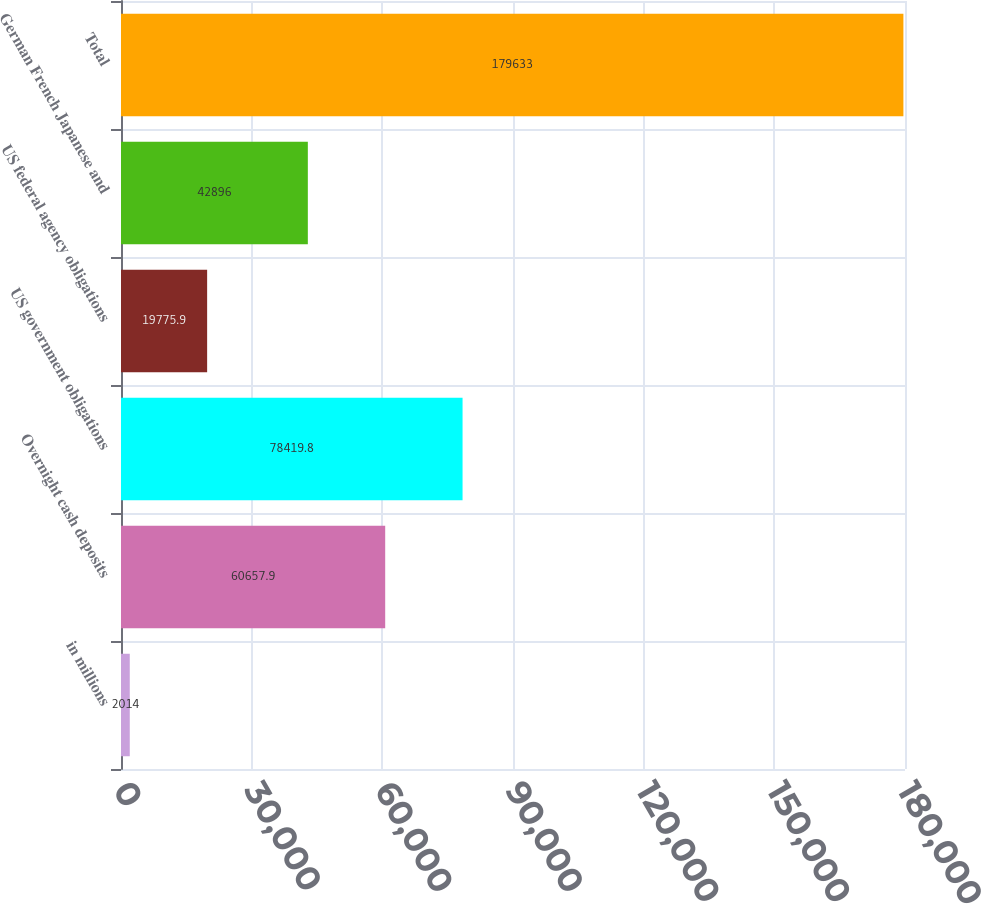<chart> <loc_0><loc_0><loc_500><loc_500><bar_chart><fcel>in millions<fcel>Overnight cash deposits<fcel>US government obligations<fcel>US federal agency obligations<fcel>German French Japanese and<fcel>Total<nl><fcel>2014<fcel>60657.9<fcel>78419.8<fcel>19775.9<fcel>42896<fcel>179633<nl></chart> 